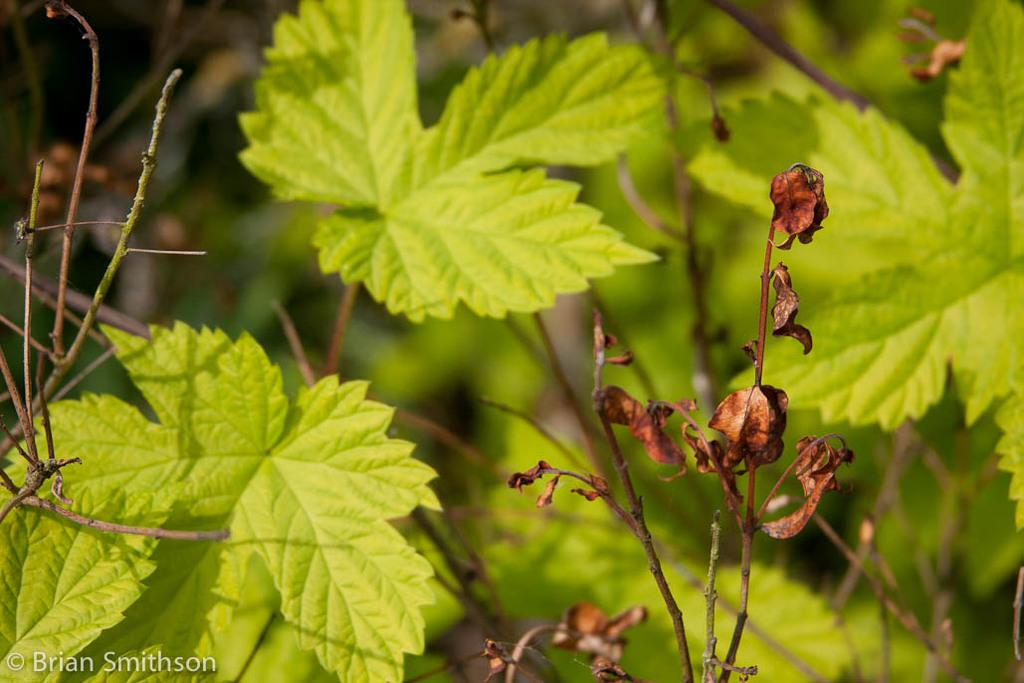What type of plant material is present in the image? There are atoms with dried leaves and stems with green leaves in the image. Can you describe the appearance of the dried leaves? The dried leaves are attached to atoms in the image. Where is the text located in the image? The text is in the left bottom corner of the image. What is the police rate of response in the image? There is no police or rate of response mentioned in the image; it features dried and green leaves with text in the corner. 